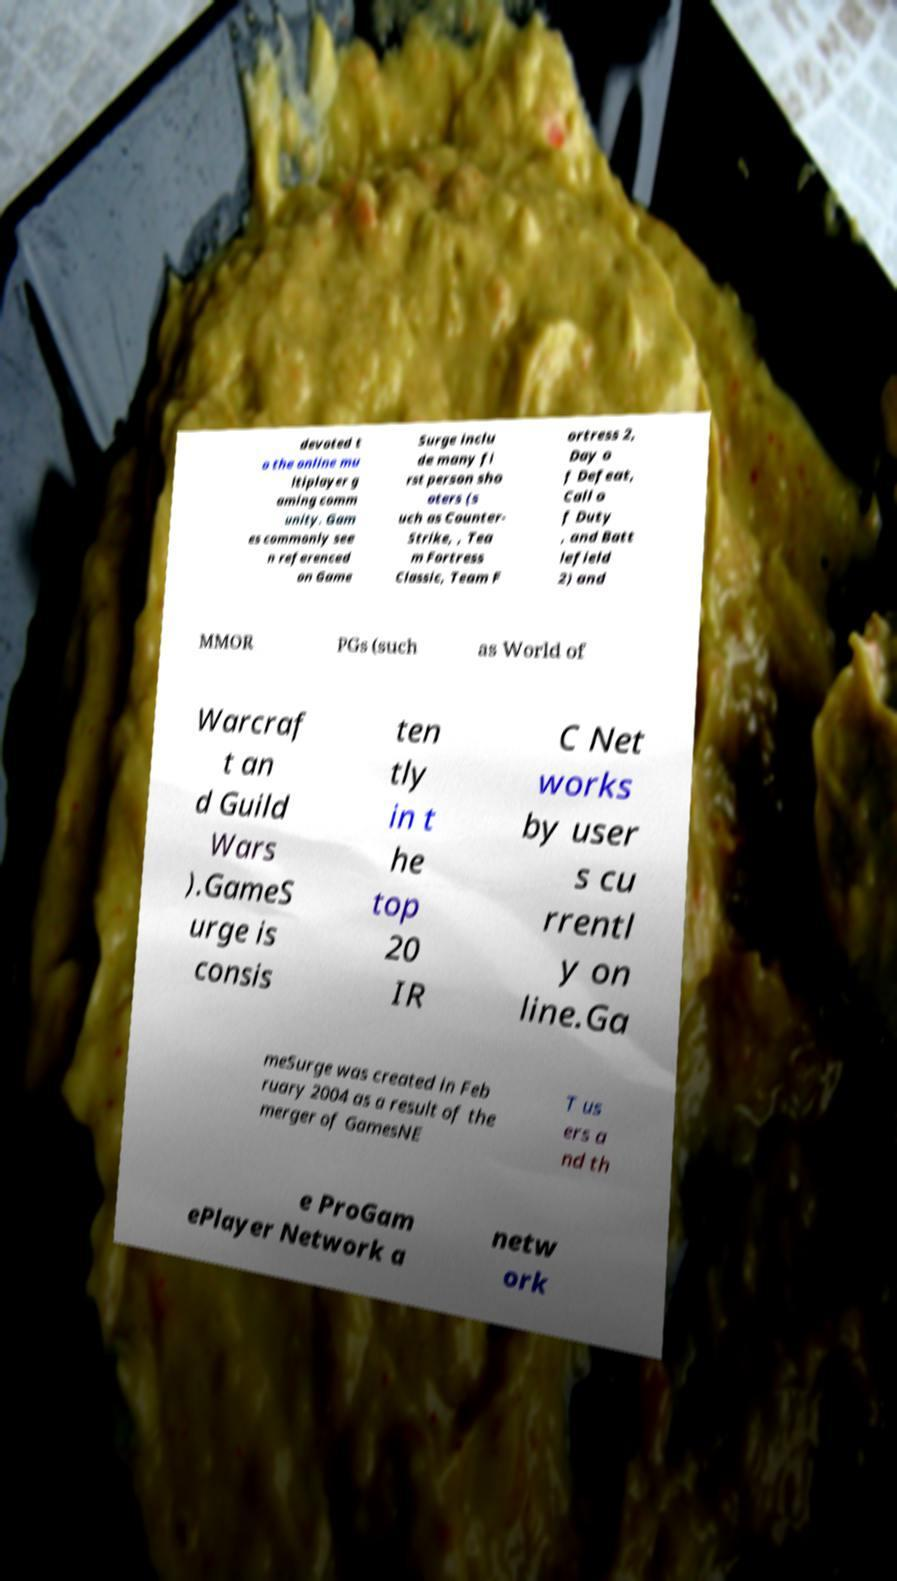What messages or text are displayed in this image? I need them in a readable, typed format. devoted t o the online mu ltiplayer g aming comm unity. Gam es commonly see n referenced on Game Surge inclu de many fi rst person sho oters (s uch as Counter- Strike, , Tea m Fortress Classic, Team F ortress 2, Day o f Defeat, Call o f Duty , and Batt lefield 2) and MMOR PGs (such as World of Warcraf t an d Guild Wars ).GameS urge is consis ten tly in t he top 20 IR C Net works by user s cu rrentl y on line.Ga meSurge was created in Feb ruary 2004 as a result of the merger of GamesNE T us ers a nd th e ProGam ePlayer Network a netw ork 